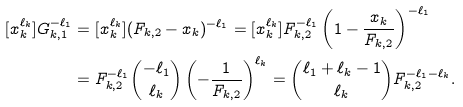Convert formula to latex. <formula><loc_0><loc_0><loc_500><loc_500>[ x _ { k } ^ { \ell _ { k } } ] G _ { k , 1 } ^ { - \ell _ { 1 } } & = [ x _ { k } ^ { \ell _ { k } } ] ( F _ { k , 2 } - x _ { k } ) ^ { - \ell _ { 1 } } = [ x _ { k } ^ { \ell _ { k } } ] F _ { k , 2 } ^ { - \ell _ { 1 } } \left ( 1 - \frac { x _ { k } } { F _ { k , 2 } } \right ) ^ { - \ell _ { 1 } } \\ & = F _ { k , 2 } ^ { - \ell _ { 1 } } \binom { - \ell _ { 1 } } { \ell _ { k } } \left ( - \frac { 1 } { F _ { k , 2 } } \right ) ^ { \ell _ { k } } = \binom { \ell _ { 1 } + \ell _ { k } - 1 } { \ell _ { k } } F _ { k , 2 } ^ { - \ell _ { 1 } - \ell _ { k } } .</formula> 